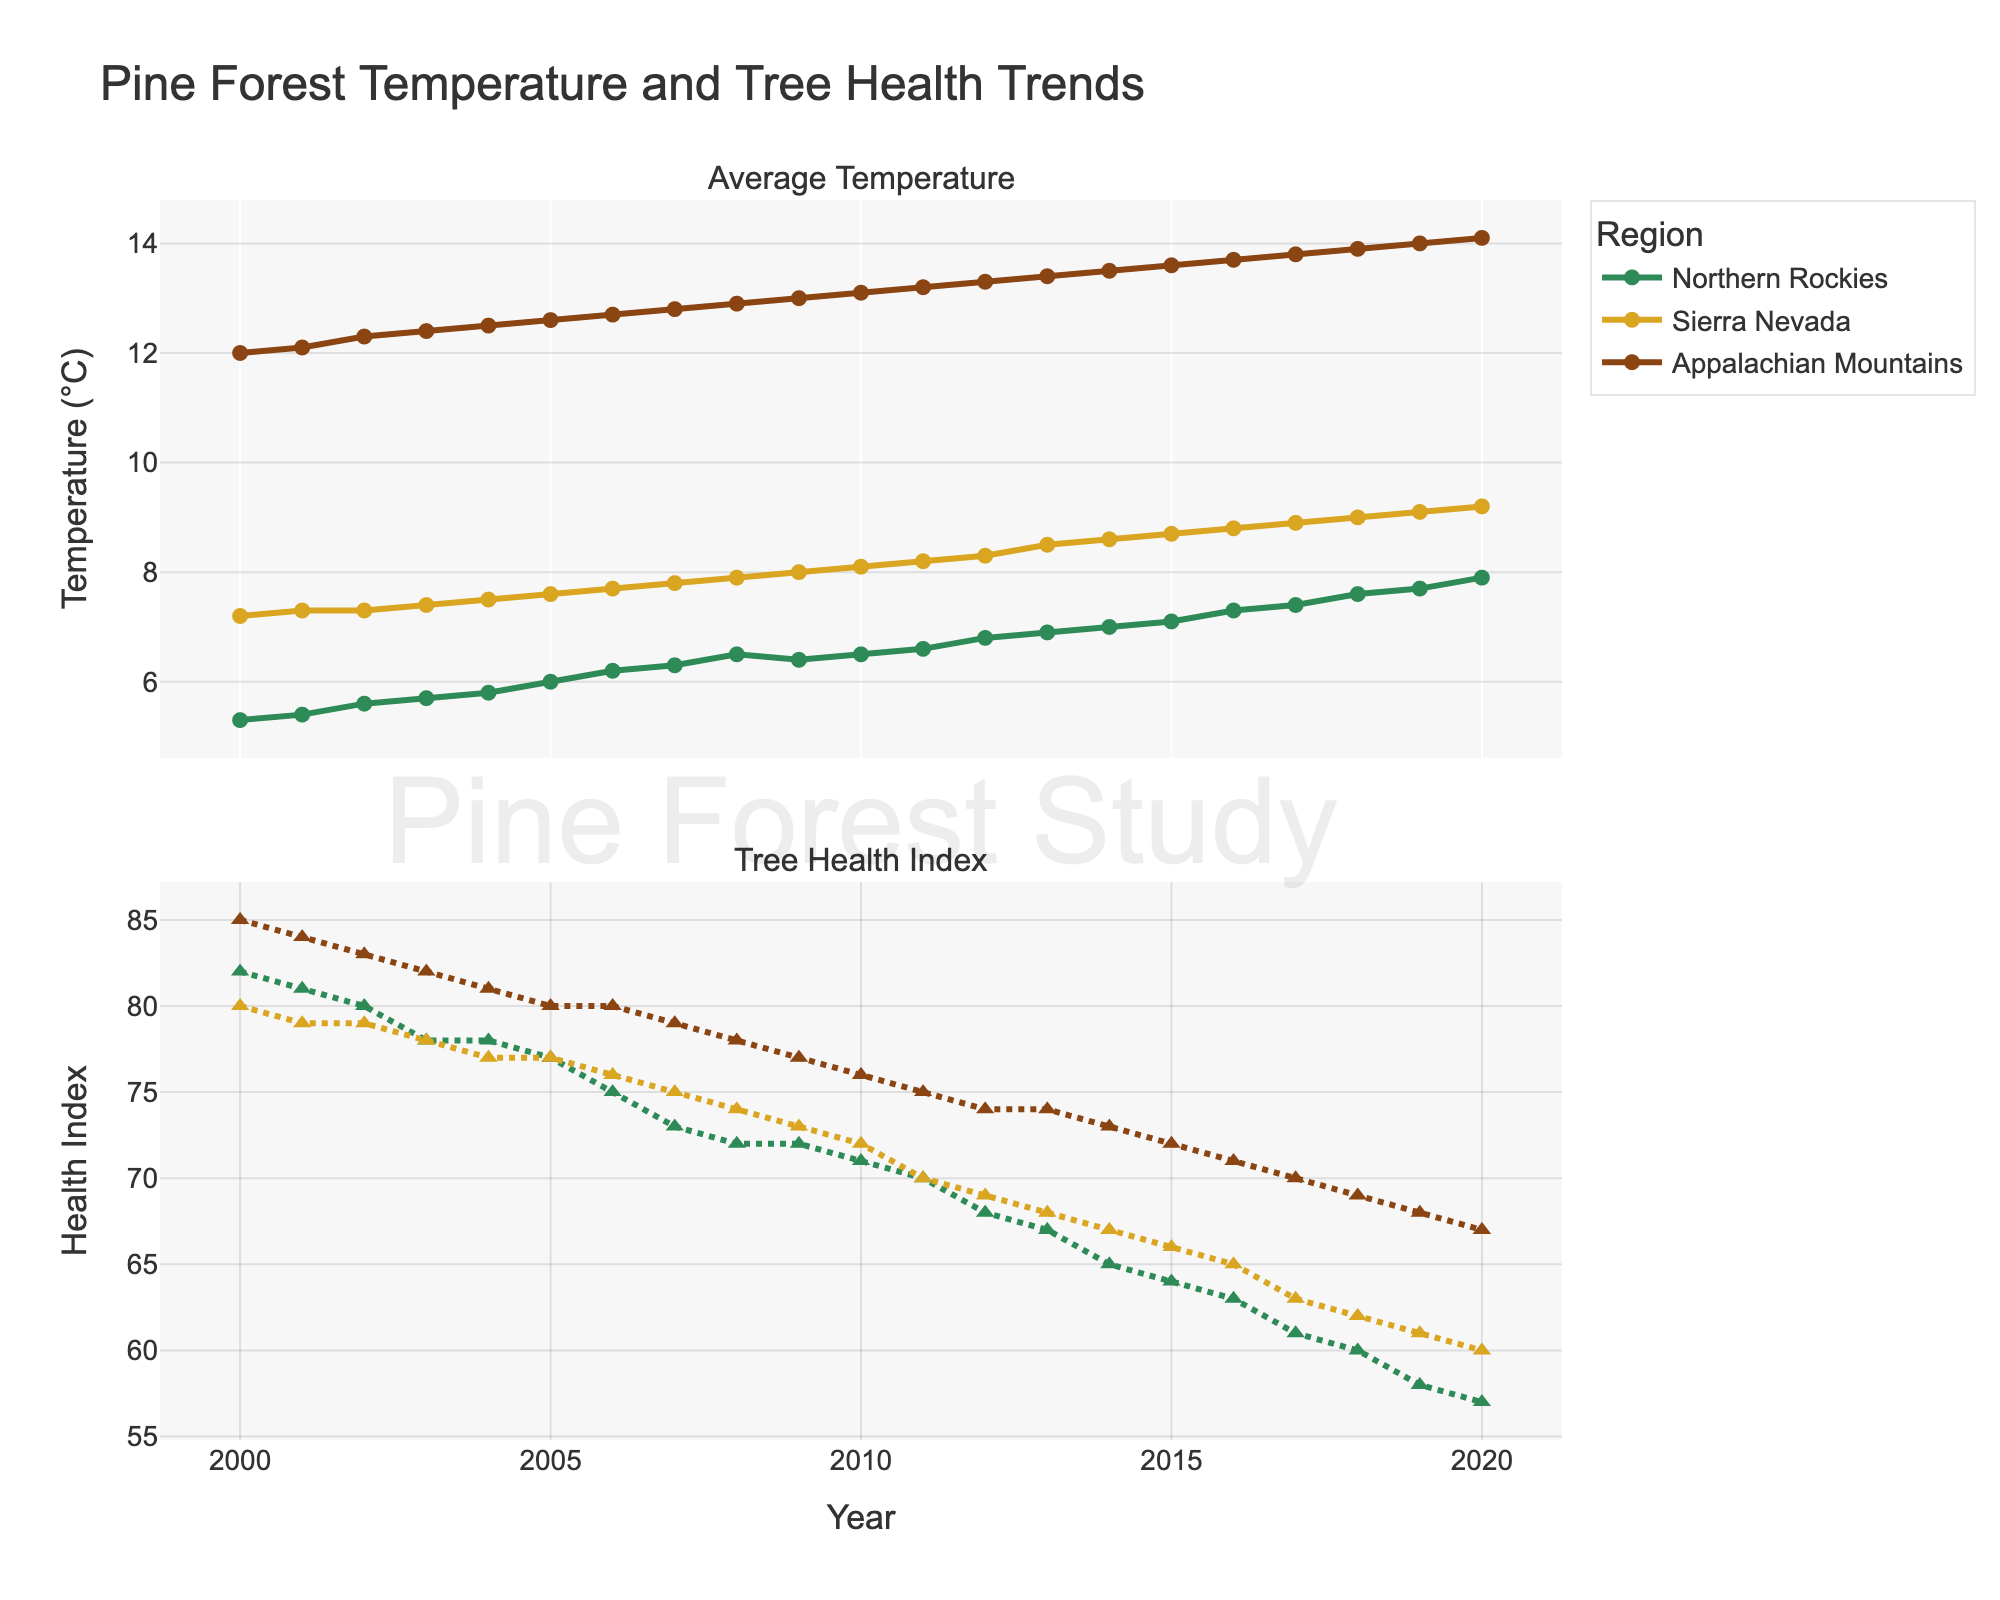What is the trend in average temperature in the Northern Rockies from 2000 to 2020? The average temperature in the Northern Rockies shows an increasing trend from 5.3°C in 2000 to 7.9°C in 2020.
Answer: Increasing How did the tree health index in the Sierra Nevada change from 2000 to 2020? The tree health index in the Sierra Nevada decreased from 80 in 2000 to 60 in 2020, indicating a decline in tree health over the 20-year period.
Answer: Decreasing Compare the average temperature trends across all three regions from 2000 to 2020. In all three regions - Northern Rockies, Sierra Nevada, and Appalachian Mountains - the average temperature shows an increasing trend. The Northern Rockies increased from 5.3°C to 7.9°C, Sierra Nevada from 7.2°C to 9.2°C, and Appalachian Mountains from 12.0°C to 14.1°C.
Answer: All regions show increasing trends Which region had the highest average temperature in 2020? In 2020, the Appalachian Mountains had the highest average temperature at 14.1°C.
Answer: Appalachian Mountains What is the relationship between average temperature and tree health in the Northern Rockies from 2000 to 2020? In the Northern Rockies, as the average temperature increased from 5.3°C in 2000 to 7.9°C in 2020, the tree health index decreased from 82 to 57, indicating a negative correlation.
Answer: Negative correlation How does the tree health index in the Appalachian Mountains in 2020 compare to that in 2000? The tree health index in the Appalachian Mountains decreased from 85 in 2000 to 67 in 2020.
Answer: Decreased For which region and in which year was the tree health index exactly 70? The tree health index was exactly 70 for the Northern Rockies in 2017 and for the Appalachian Mountains in 2017.
Answer: Northern Rockies (2017), Appalachian Mountains (2017) What is the difference in average temperature between the Sierra Nevada and the Northern Rockies in 2010? In 2010, the average temperature in the Sierra Nevada was 8.1°C and in the Northern Rockies it was 6.5°C. The difference is 8.1°C - 6.5°C = 1.6°C.
Answer: 1.6°C Which region experienced the most significant decline in tree health index from 2000 to 2020? All regions experienced declines, but the Northern Rockies showed the steepest decline from 82 in 2000 to 57 in 2020.
Answer: Northern Rockies 